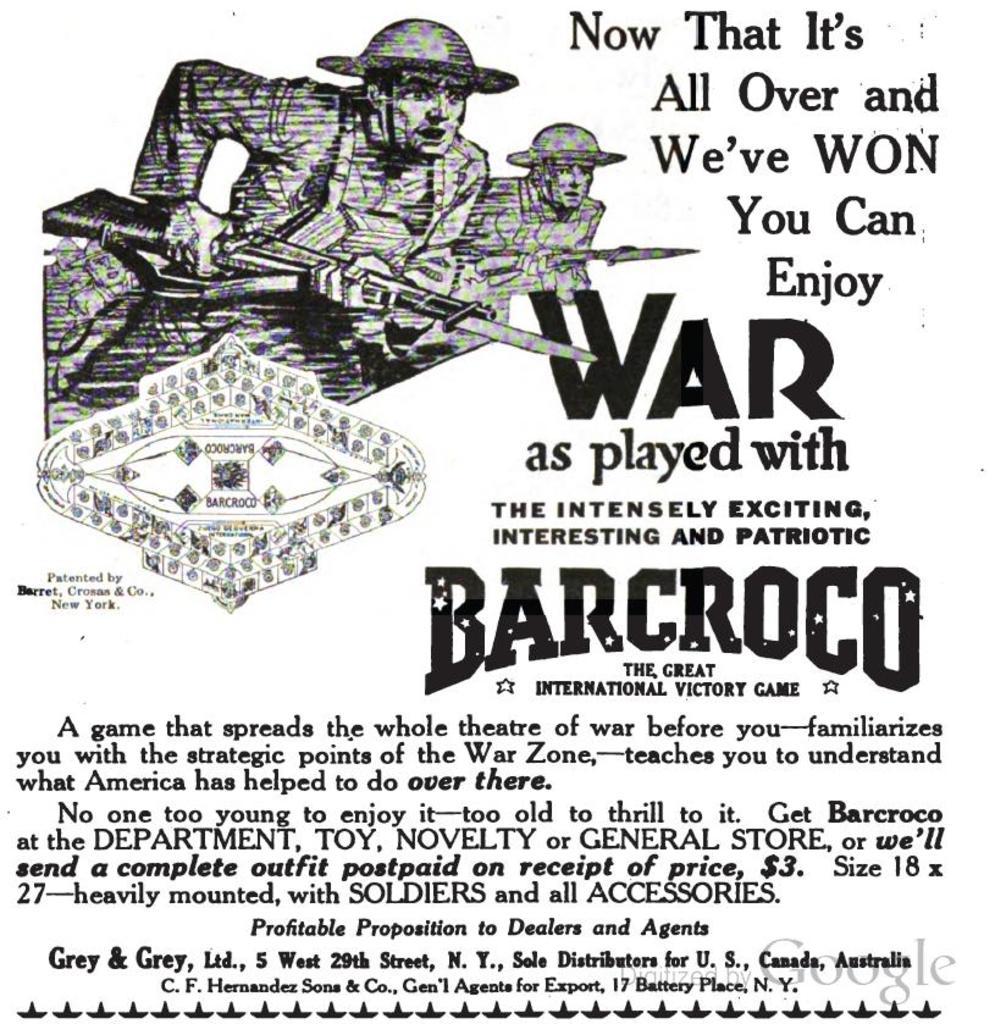What is the price shown on this ad?
Keep it short and to the point. $3. What company makes this?
Your answer should be very brief. Barcroco. 